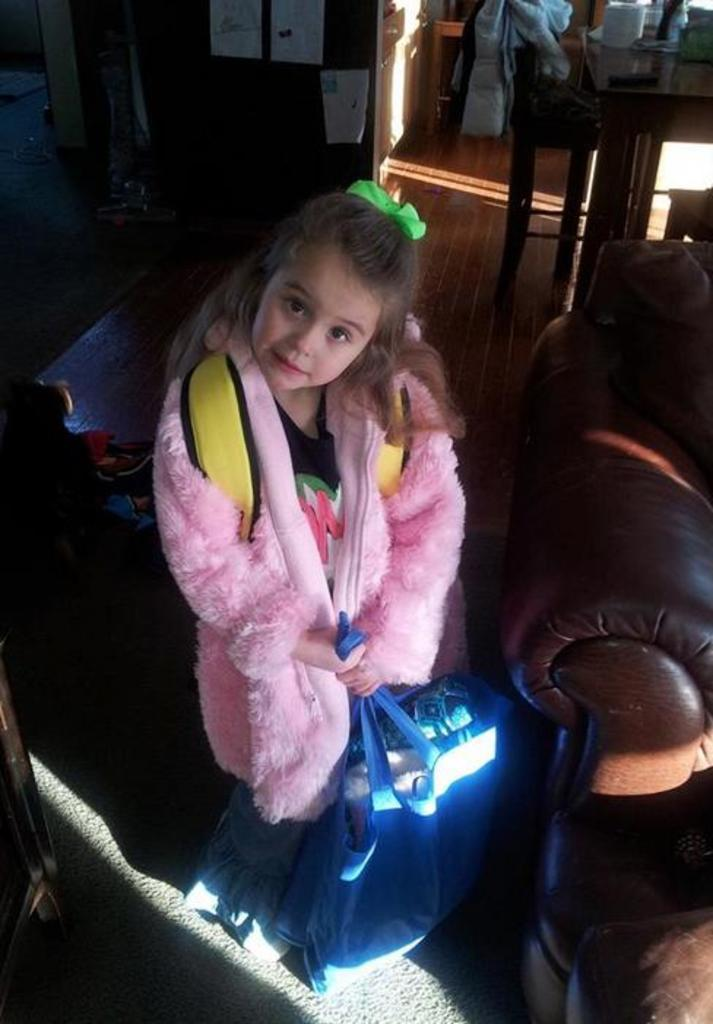Who is the main subject in the image? There is a girl in the image. What is the girl holding in the image? The girl is holding a bag. What piece of furniture is located beside the girl? There is a couch beside the girl. What type of surface is visible in the background of the image? There is a floor visible in the background of the image. What other piece of furniture can be seen in the background of the image? There is a table in the background of the image. What type of sugar is being used to fuel the girl's driving in the image? There is no driving or sugar present in the image; it features a girl holding a bag beside a couch and a table in the background. 